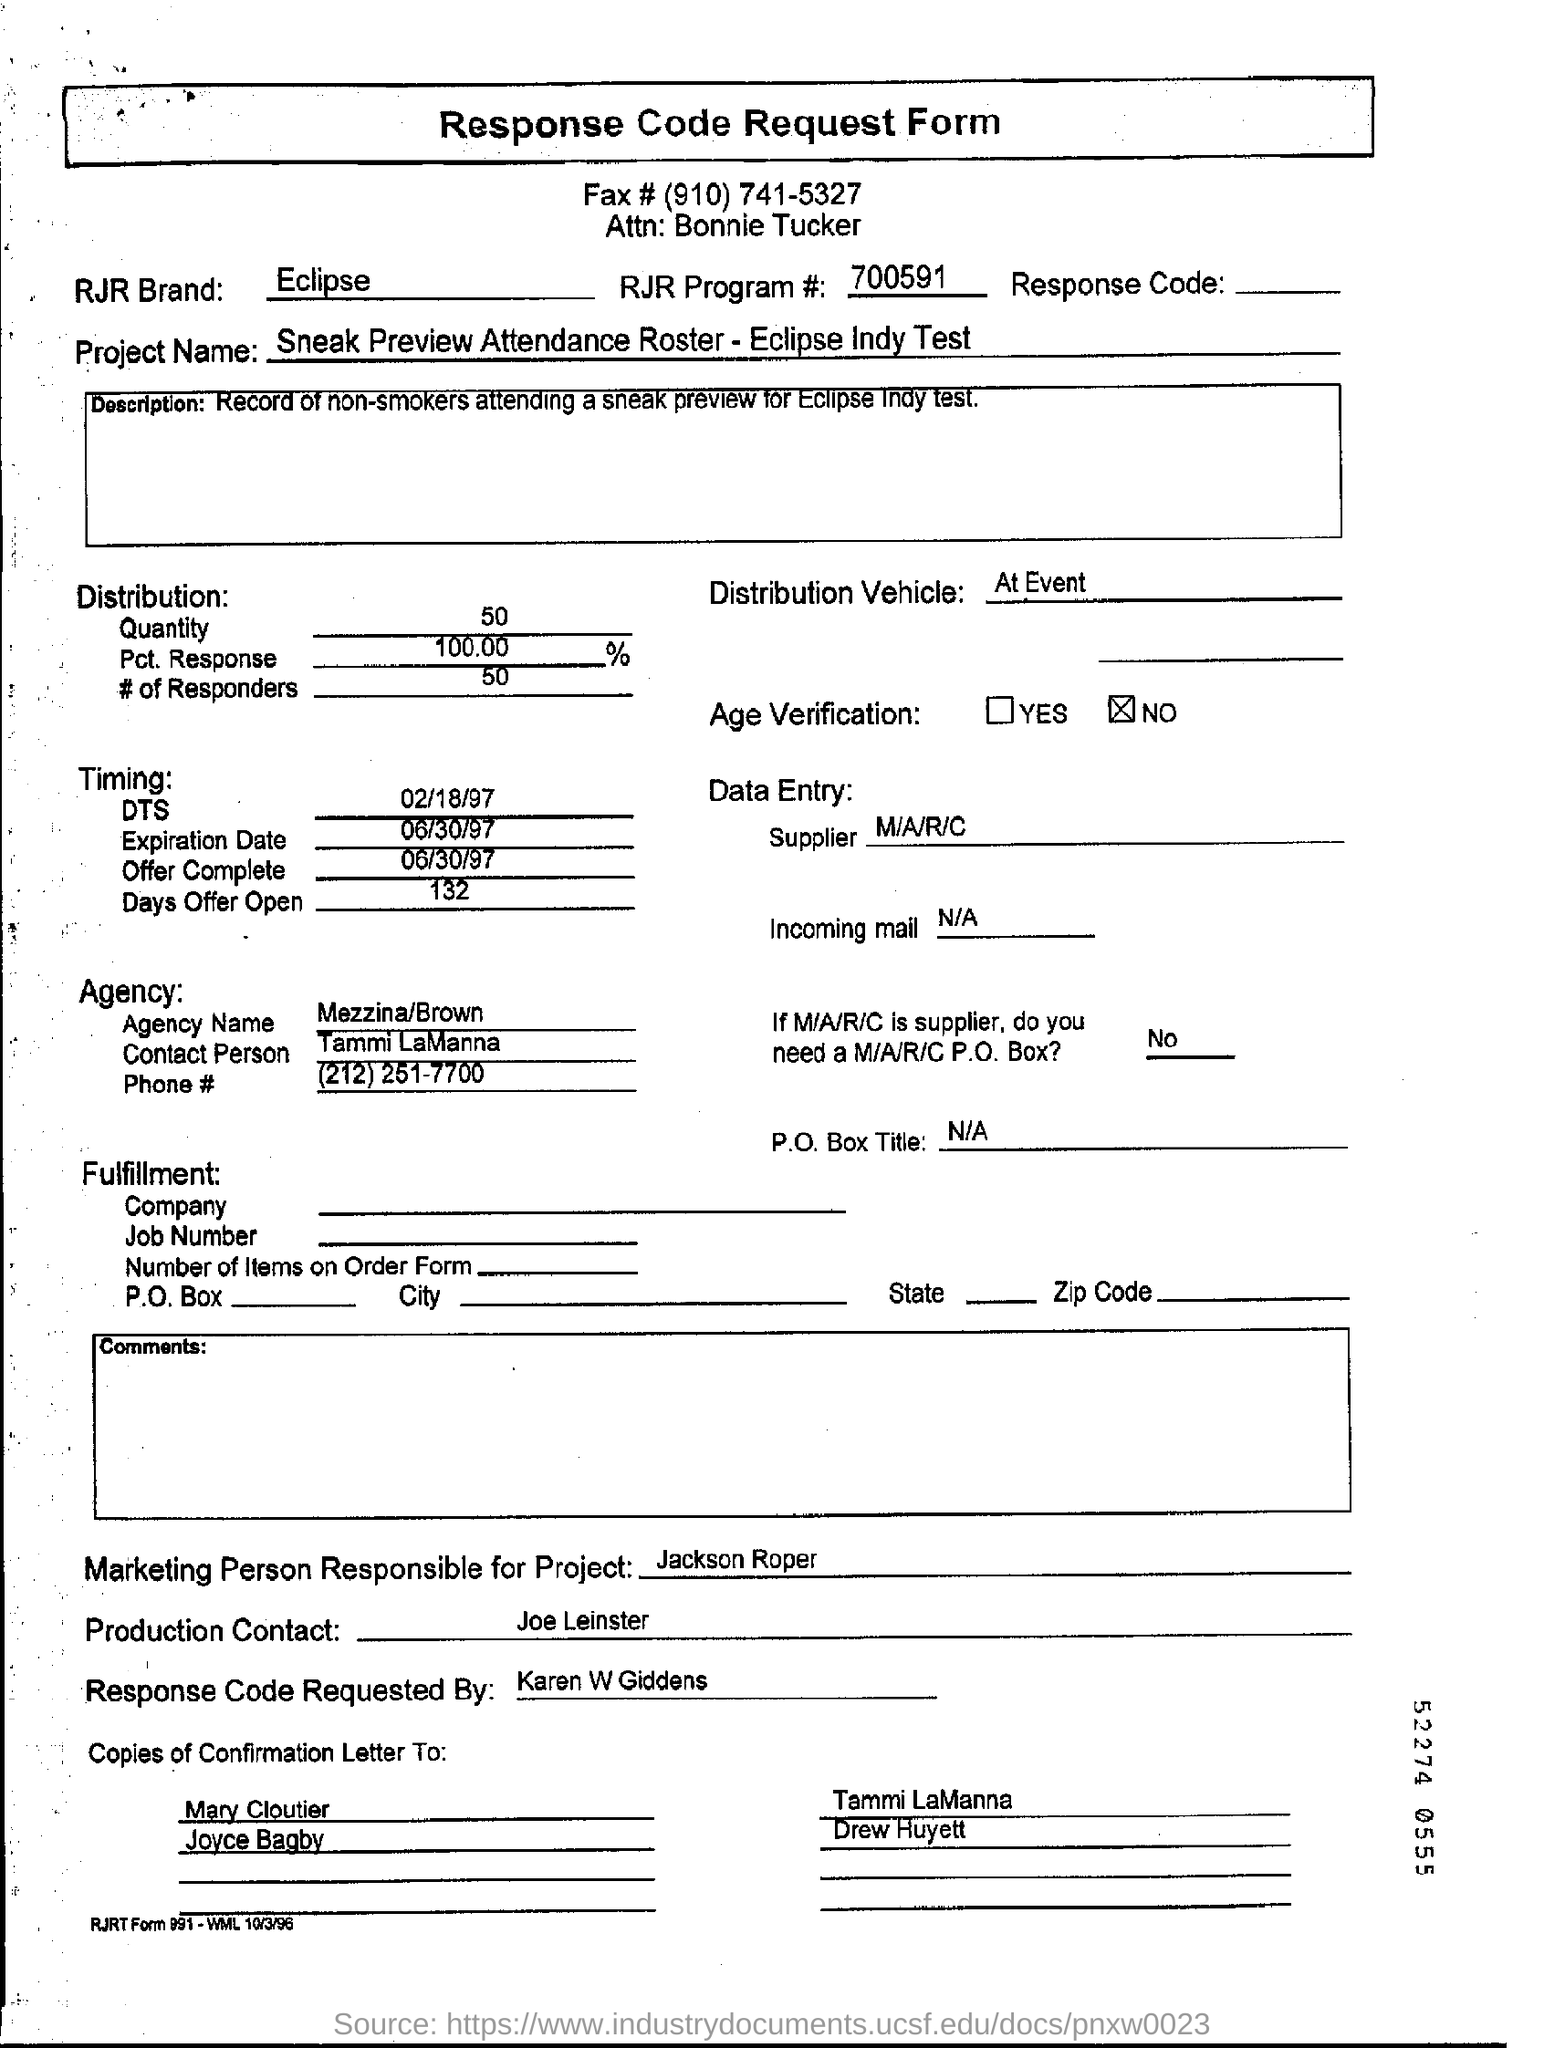Outline some significant characteristics in this image. Jackson Roper is the marketing person responsible for this. The distribution of vehicles is at the event. The sentence "What is RJR program number? RJ? 700591.." is a question asking for information about a specific program number associated with RJR. The agency name is Mezzina/Brown. 